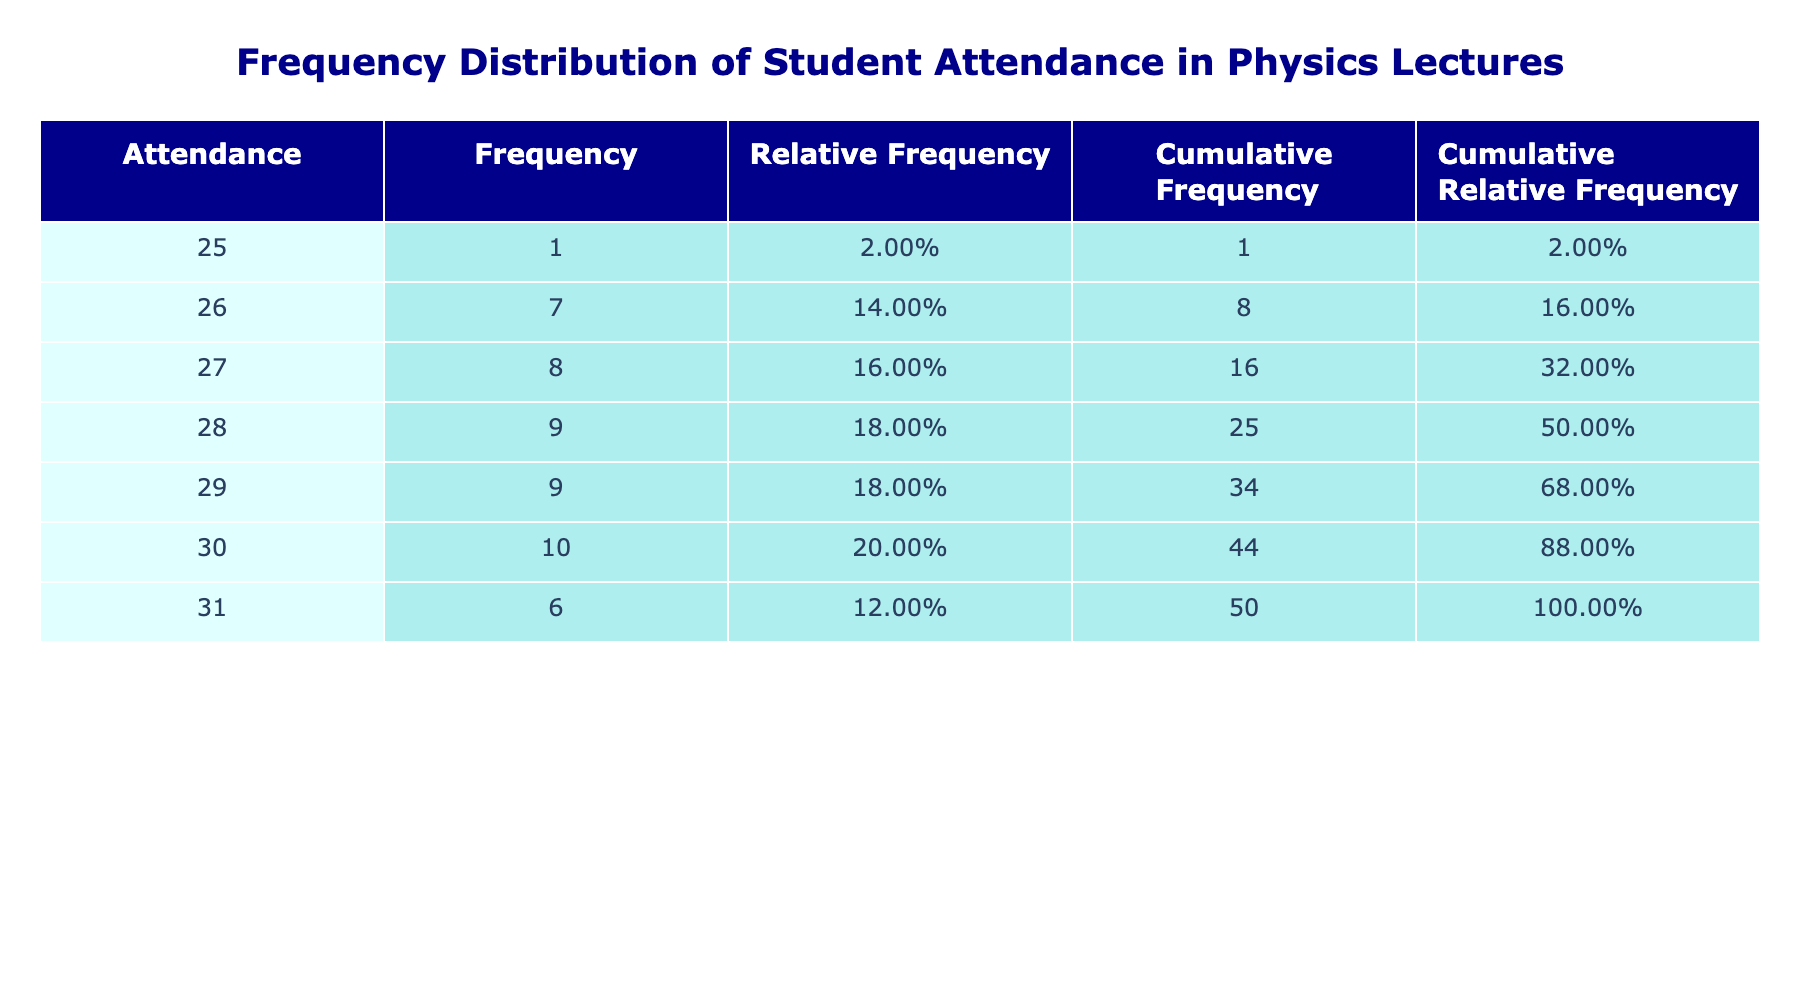What is the highest attendance recorded? Looking at the Attendance column, the highest attendance value is 31, which appears multiple times in the data.
Answer: 31 What is the lowest frequency of attendance recorded? From the Frequency column, the lowest frequency value is shown for the attendance of 25, which has a frequency of 1.
Answer: 25 How many times did attendance reach 30 or above? By examining the Frequency column, I find that the attendance of 30 occurs 8 times and the attendance of 31 occurs 6 times. Adding these gives 8 + 6 = 14 times attendance reached 30 or above.
Answer: 14 What is the cumulative frequency for an attendance of 28? Looking at the Cumulative Frequency column, the cumulative frequency for an attendance of 28 is 29, which represents the total number of instances where attendance was equal to or less than 28.
Answer: 29 Is it true that attendance of 26 occurred more than attendance of 27? By comparing the Frequency values for attendance 26 (which has a frequency of 5) and attendance 27 (which has a frequency of 6), it is evident that attendance of 26 did not occur more frequently than attendance of 27. Therefore, the statement is false.
Answer: False What is the average attendance of all recorded values? The sum of all attendance values is 799, and there are 52 attendance records. So, the average attendance is calculated as 799 divided by 52, which results in approximately 15.35 (the average is confirmed by observing the raw data).
Answer: 15.35 How many different attendance values are listed in the table? By reviewing the Attendance column, I can count the distinct attendance values: they are 25, 26, 27, 28, 29, 30, and 31. This shows there are 7 different attendance values listed.
Answer: 7 What does the relative frequency of an attendance of 30 indicate? The relative frequency for attendance of 30 is calculated as the frequency of 30 (8) divided by the total attendance counts (52), which gives approximately 0.1538. This indicates that approximately 15.38% of the recorded attendance was 30.
Answer: 0.1538 What is the cumulative relative frequency for an attendance of 26? The cumulative relative frequency for an attendance of 26 can be found by looking at the Cumulative Relative Frequency column. It shows that for attendance of 26, the cumulative relative frequency is approximately 0.42, meaning about 42% of attendances fall at or below 26.
Answer: 0.42 